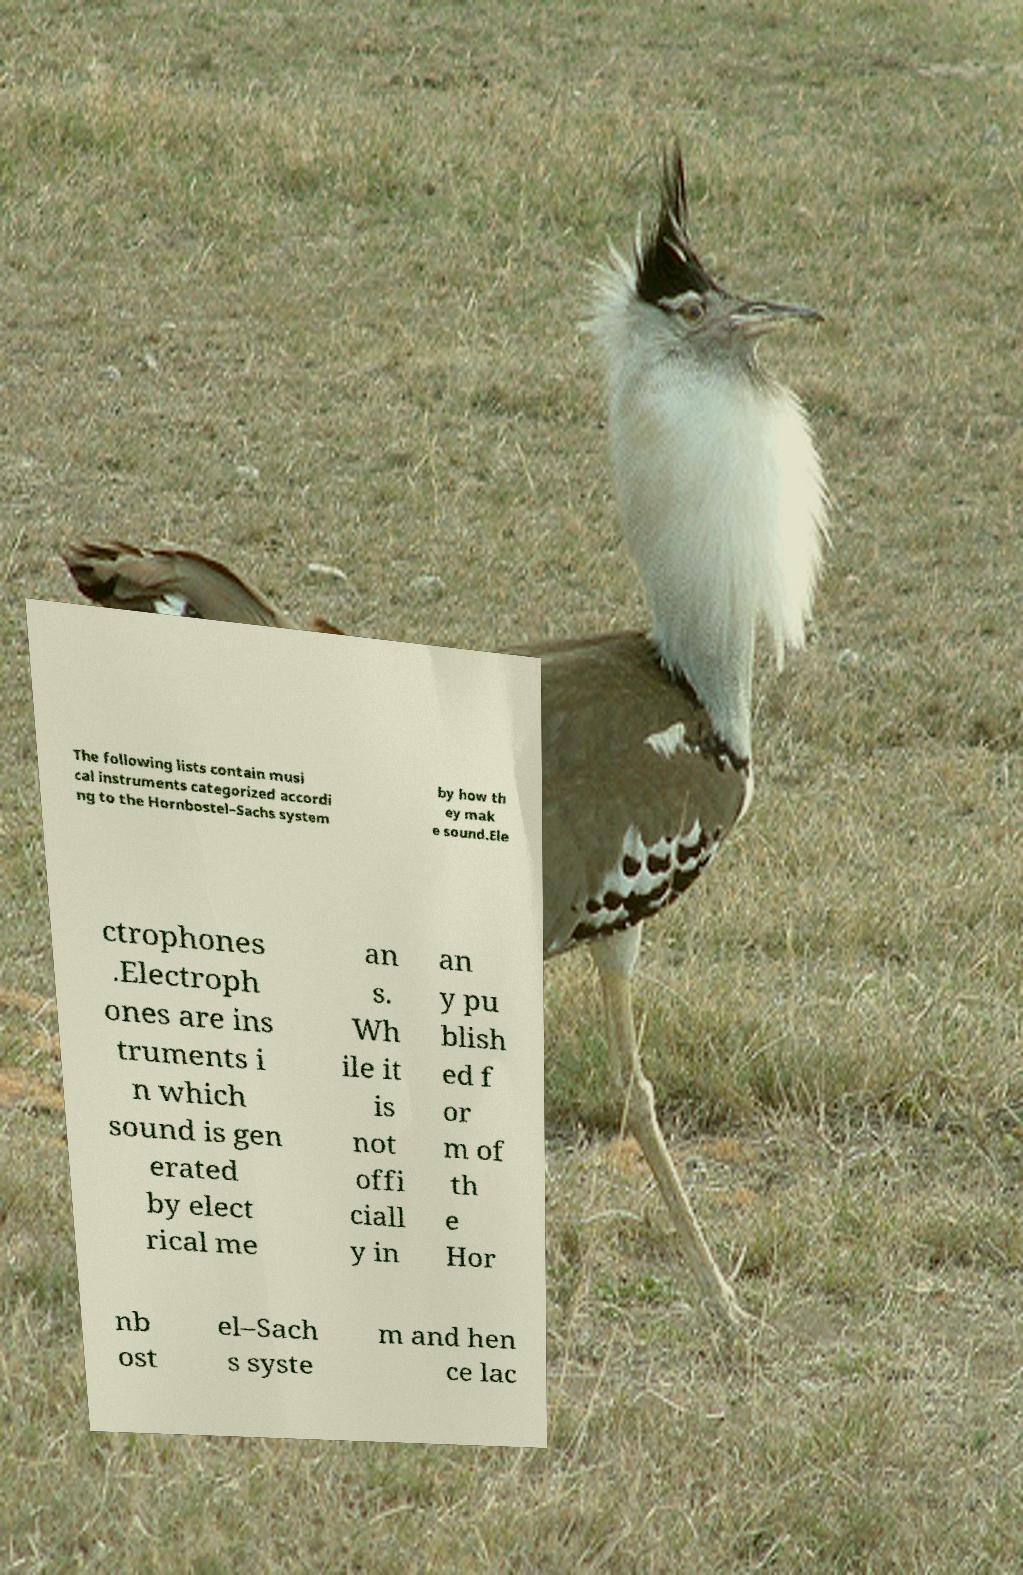What messages or text are displayed in this image? I need them in a readable, typed format. The following lists contain musi cal instruments categorized accordi ng to the Hornbostel–Sachs system by how th ey mak e sound.Ele ctrophones .Electroph ones are ins truments i n which sound is gen erated by elect rical me an s. Wh ile it is not offi ciall y in an y pu blish ed f or m of th e Hor nb ost el–Sach s syste m and hen ce lac 